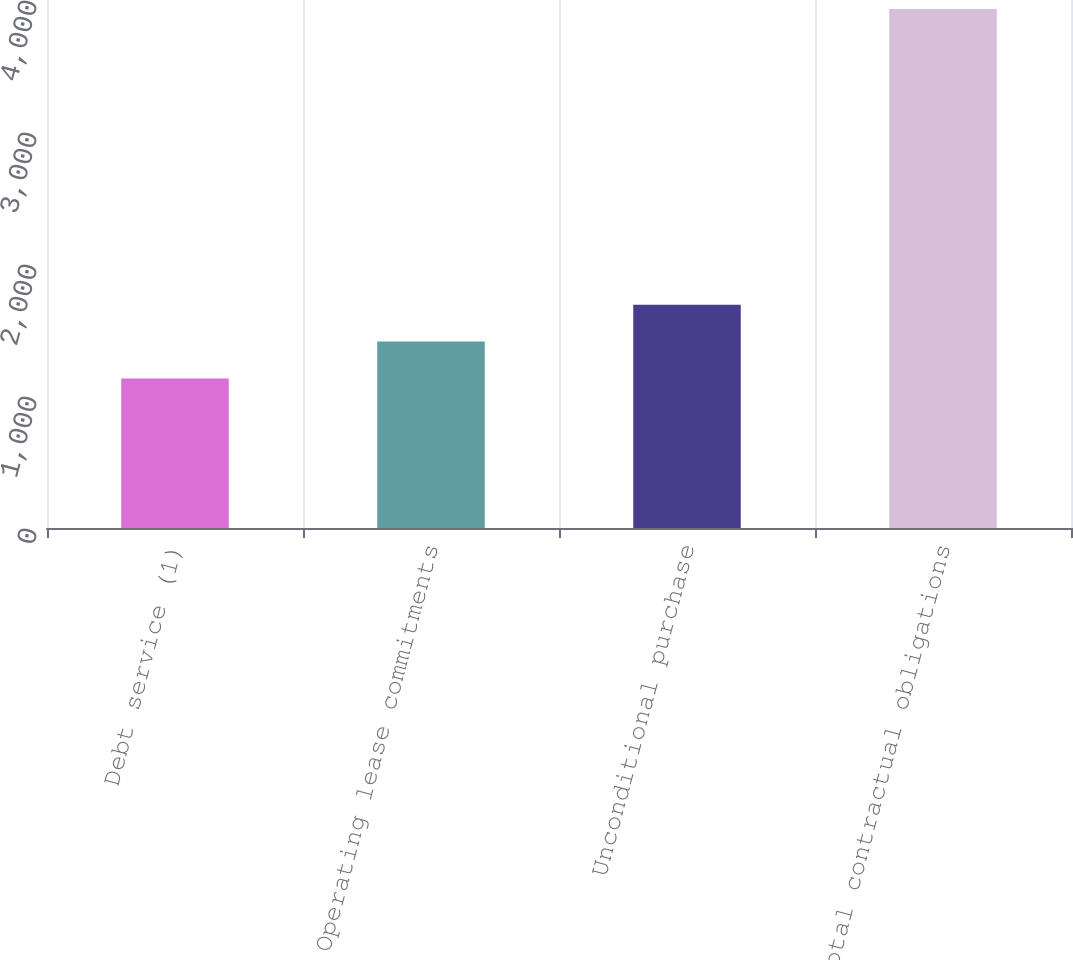<chart> <loc_0><loc_0><loc_500><loc_500><bar_chart><fcel>Debt service (1)<fcel>Operating lease commitments<fcel>Unconditional purchase<fcel>Total contractual obligations<nl><fcel>1132.1<fcel>1411.98<fcel>1691.86<fcel>3930.9<nl></chart> 